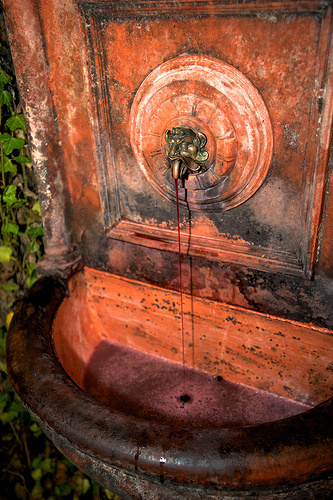<image>
Can you confirm if the water is in front of the spigot? Yes. The water is positioned in front of the spigot, appearing closer to the camera viewpoint. 